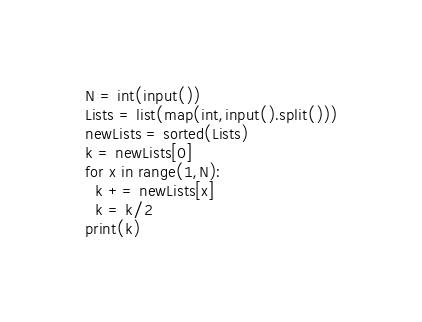Convert code to text. <code><loc_0><loc_0><loc_500><loc_500><_Python_>N = int(input())
Lists = list(map(int,input().split()))
newLists = sorted(Lists)
k = newLists[0]
for x in range(1,N):
  k += newLists[x]
  k = k/2
print(k)
</code> 